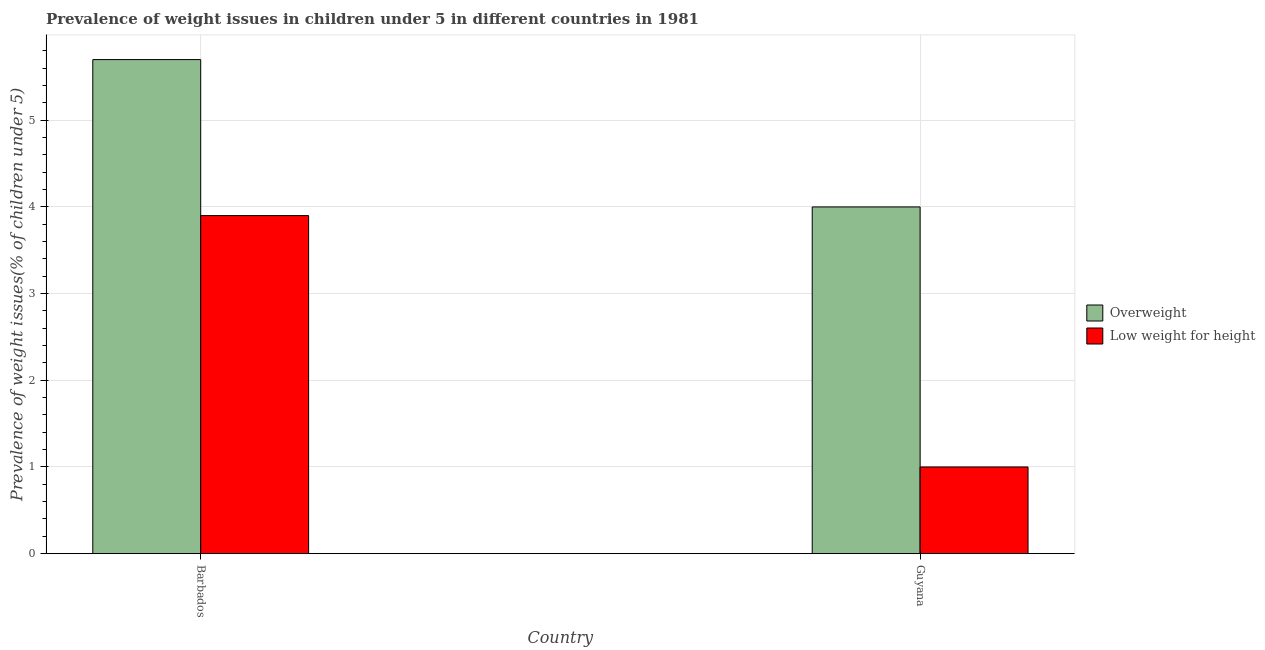How many groups of bars are there?
Offer a very short reply. 2. What is the label of the 1st group of bars from the left?
Ensure brevity in your answer.  Barbados. In how many cases, is the number of bars for a given country not equal to the number of legend labels?
Make the answer very short. 0. What is the percentage of underweight children in Barbados?
Provide a short and direct response. 3.9. Across all countries, what is the maximum percentage of underweight children?
Make the answer very short. 3.9. Across all countries, what is the minimum percentage of underweight children?
Your answer should be very brief. 1. In which country was the percentage of underweight children maximum?
Your answer should be compact. Barbados. In which country was the percentage of overweight children minimum?
Ensure brevity in your answer.  Guyana. What is the total percentage of underweight children in the graph?
Give a very brief answer. 4.9. What is the difference between the percentage of overweight children in Barbados and that in Guyana?
Your answer should be very brief. 1.7. What is the difference between the percentage of overweight children in Guyana and the percentage of underweight children in Barbados?
Ensure brevity in your answer.  0.1. What is the average percentage of underweight children per country?
Provide a succinct answer. 2.45. What is the difference between the percentage of underweight children and percentage of overweight children in Guyana?
Keep it short and to the point. -3. What is the ratio of the percentage of underweight children in Barbados to that in Guyana?
Give a very brief answer. 3.9. Is the percentage of overweight children in Barbados less than that in Guyana?
Ensure brevity in your answer.  No. What does the 2nd bar from the left in Guyana represents?
Give a very brief answer. Low weight for height. What does the 1st bar from the right in Barbados represents?
Make the answer very short. Low weight for height. Are all the bars in the graph horizontal?
Your answer should be compact. No. Does the graph contain grids?
Make the answer very short. Yes. Where does the legend appear in the graph?
Your answer should be compact. Center right. How many legend labels are there?
Offer a very short reply. 2. How are the legend labels stacked?
Give a very brief answer. Vertical. What is the title of the graph?
Your response must be concise. Prevalence of weight issues in children under 5 in different countries in 1981. Does "Short-term debt" appear as one of the legend labels in the graph?
Ensure brevity in your answer.  No. What is the label or title of the X-axis?
Give a very brief answer. Country. What is the label or title of the Y-axis?
Your response must be concise. Prevalence of weight issues(% of children under 5). What is the Prevalence of weight issues(% of children under 5) in Overweight in Barbados?
Your answer should be very brief. 5.7. What is the Prevalence of weight issues(% of children under 5) of Low weight for height in Barbados?
Keep it short and to the point. 3.9. What is the Prevalence of weight issues(% of children under 5) of Overweight in Guyana?
Your answer should be very brief. 4. Across all countries, what is the maximum Prevalence of weight issues(% of children under 5) in Overweight?
Keep it short and to the point. 5.7. Across all countries, what is the maximum Prevalence of weight issues(% of children under 5) in Low weight for height?
Ensure brevity in your answer.  3.9. Across all countries, what is the minimum Prevalence of weight issues(% of children under 5) of Low weight for height?
Your answer should be compact. 1. What is the total Prevalence of weight issues(% of children under 5) in Low weight for height in the graph?
Your answer should be compact. 4.9. What is the difference between the Prevalence of weight issues(% of children under 5) of Overweight in Barbados and the Prevalence of weight issues(% of children under 5) of Low weight for height in Guyana?
Make the answer very short. 4.7. What is the average Prevalence of weight issues(% of children under 5) of Overweight per country?
Provide a short and direct response. 4.85. What is the average Prevalence of weight issues(% of children under 5) in Low weight for height per country?
Ensure brevity in your answer.  2.45. What is the ratio of the Prevalence of weight issues(% of children under 5) of Overweight in Barbados to that in Guyana?
Your answer should be very brief. 1.43. What is the ratio of the Prevalence of weight issues(% of children under 5) of Low weight for height in Barbados to that in Guyana?
Your answer should be compact. 3.9. What is the difference between the highest and the second highest Prevalence of weight issues(% of children under 5) of Low weight for height?
Make the answer very short. 2.9. What is the difference between the highest and the lowest Prevalence of weight issues(% of children under 5) in Overweight?
Give a very brief answer. 1.7. What is the difference between the highest and the lowest Prevalence of weight issues(% of children under 5) of Low weight for height?
Make the answer very short. 2.9. 